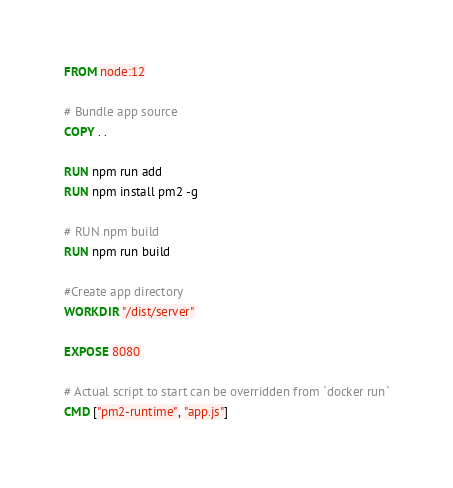<code> <loc_0><loc_0><loc_500><loc_500><_Dockerfile_>FROM node:12

# Bundle app source
COPY . .

RUN npm run add
RUN npm install pm2 -g

# RUN npm build
RUN npm run build

#Create app directory
WORKDIR "/dist/server"

EXPOSE 8080

# Actual script to start can be overridden from `docker run`
CMD ["pm2-runtime", "app.js"]</code> 